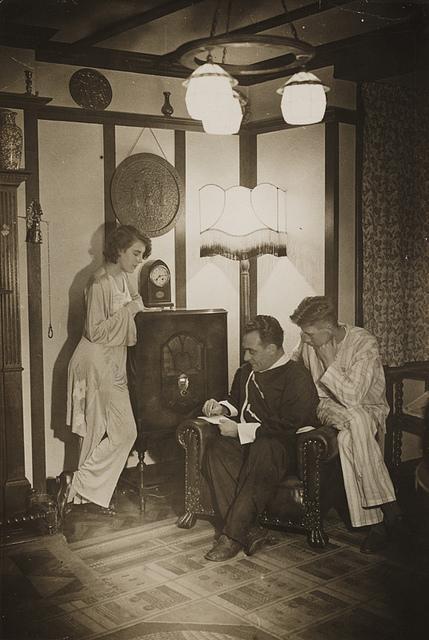How many people can be seen?
Give a very brief answer. 3. How many birds are in the picture?
Give a very brief answer. 0. 